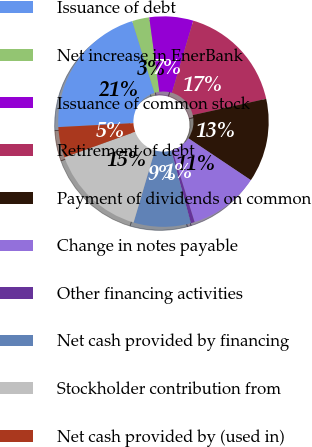Convert chart to OTSL. <chart><loc_0><loc_0><loc_500><loc_500><pie_chart><fcel>Issuance of debt<fcel>Net increase in EnerBank<fcel>Issuance of common stock<fcel>Retirement of debt<fcel>Payment of dividends on common<fcel>Change in notes payable<fcel>Other financing activities<fcel>Net cash provided by financing<fcel>Stockholder contribution from<fcel>Net cash provided by (used in)<nl><fcel>21.04%<fcel>2.64%<fcel>6.73%<fcel>16.95%<fcel>12.86%<fcel>10.82%<fcel>0.59%<fcel>8.77%<fcel>14.91%<fcel>4.68%<nl></chart> 